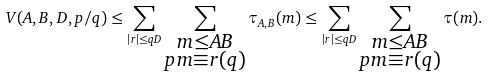Convert formula to latex. <formula><loc_0><loc_0><loc_500><loc_500>V ( A , B , D , p / q ) \leq \sum _ { | r | \leq q D } \sum _ { \substack { m \leq A B \\ p m \equiv r ( q ) } } \tau _ { A , B } ( m ) \leq \sum _ { | r | \leq q D } \sum _ { \substack { m \leq A B \\ p m \equiv r ( q ) } } \tau ( m ) .</formula> 